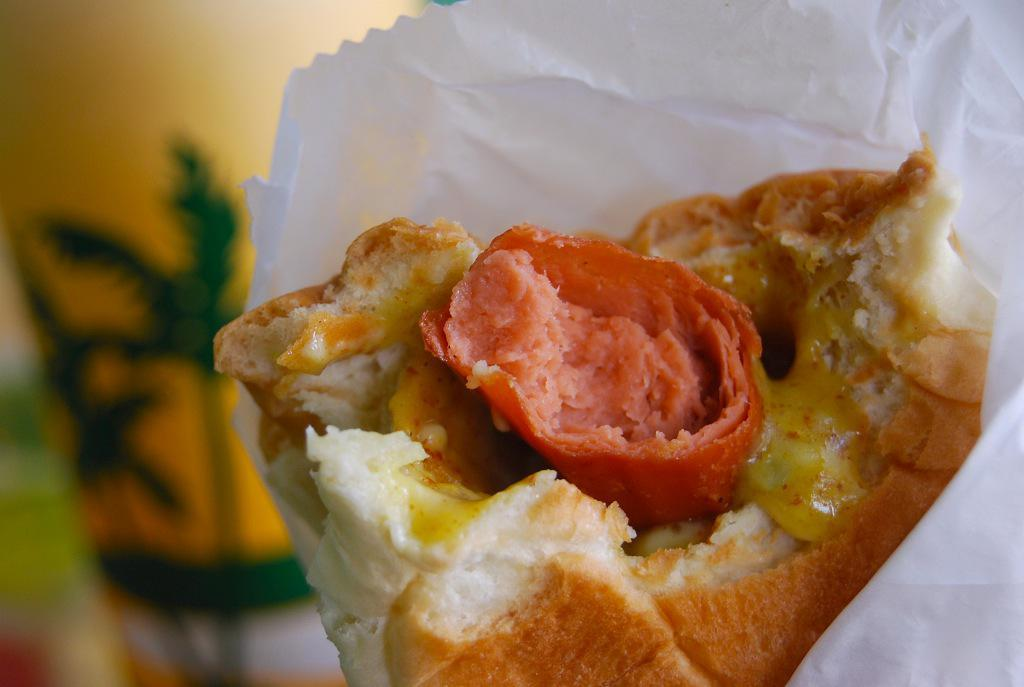What type of food item is present in the image? There is a food item with sausage in the image. How is the food item packaged? The food item is in a white paper. What can be seen in the background of the image? There is a yellow and green color object in the background of the image. Can you describe the background's appearance? The background is blurred. What type of beast can be seen in the image? There is no beast present in the image. How does the food item care for the environment in the image? The food item does not have the ability to care for the environment; it is an inanimate object. 